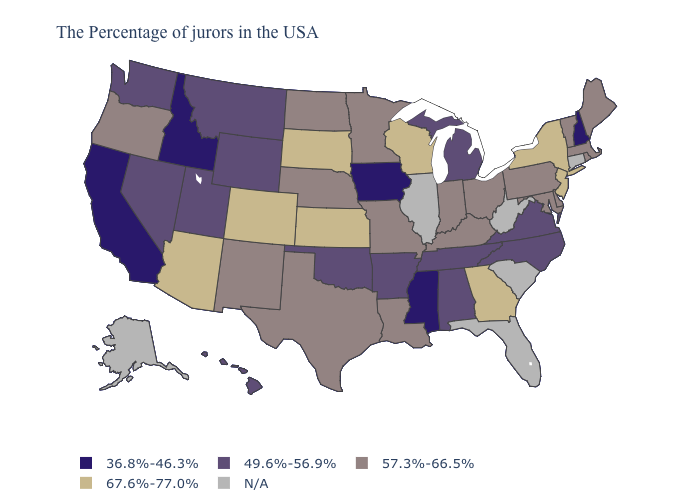Does South Dakota have the highest value in the USA?
Answer briefly. Yes. Name the states that have a value in the range 36.8%-46.3%?
Quick response, please. New Hampshire, Mississippi, Iowa, Idaho, California. Does Delaware have the lowest value in the South?
Quick response, please. No. What is the value of Oregon?
Answer briefly. 57.3%-66.5%. Among the states that border Tennessee , does Missouri have the lowest value?
Quick response, please. No. What is the lowest value in the West?
Answer briefly. 36.8%-46.3%. What is the value of Idaho?
Quick response, please. 36.8%-46.3%. Name the states that have a value in the range 67.6%-77.0%?
Keep it brief. New York, New Jersey, Georgia, Wisconsin, Kansas, South Dakota, Colorado, Arizona. What is the value of Vermont?
Be succinct. 57.3%-66.5%. Name the states that have a value in the range N/A?
Be succinct. Connecticut, South Carolina, West Virginia, Florida, Illinois, Alaska. Which states have the lowest value in the USA?
Write a very short answer. New Hampshire, Mississippi, Iowa, Idaho, California. Name the states that have a value in the range N/A?
Write a very short answer. Connecticut, South Carolina, West Virginia, Florida, Illinois, Alaska. Name the states that have a value in the range N/A?
Short answer required. Connecticut, South Carolina, West Virginia, Florida, Illinois, Alaska. 